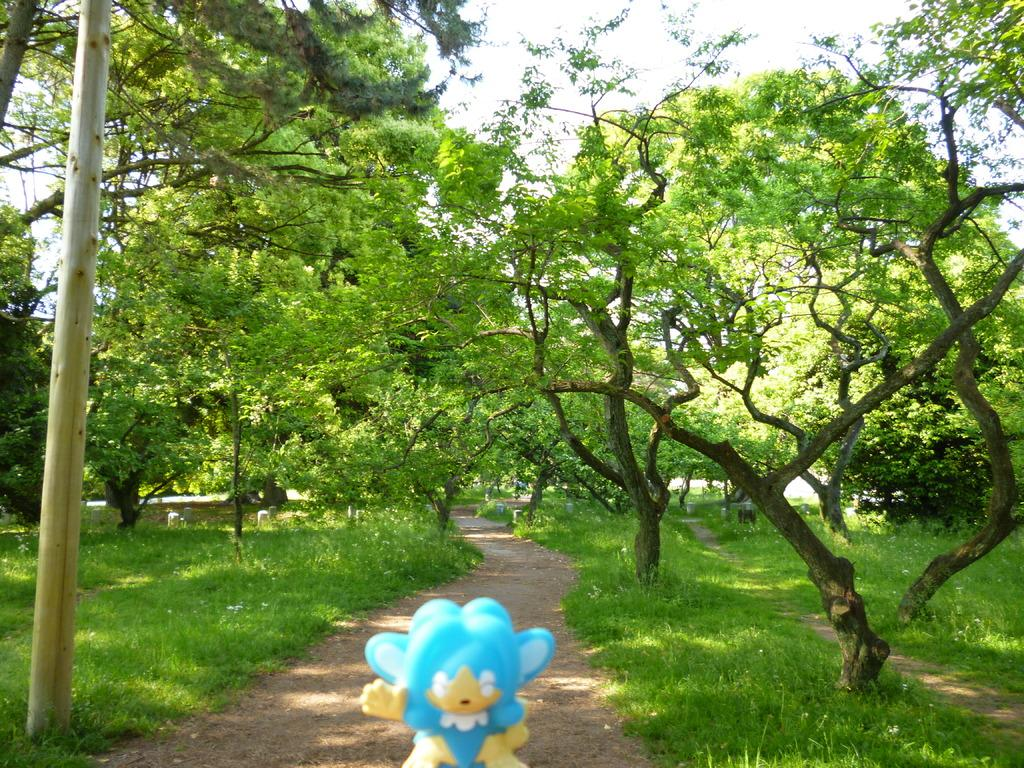What type of natural environment is depicted in the image? There is a lot of grass and trees in the image, suggesting a natural environment. Can you describe the toy in the foreground of the image? Unfortunately, the facts provided do not give any details about the toy, so we cannot describe it. What type of trees are present in the image? The facts provided do not specify the type of trees, so we cannot identify them. What note is written on the ground in the image? There is no note written on the ground in the image. What is the purpose of the grass in the image? The grass in the image does not have a specific purpose; it is a natural element of the depicted environment. 